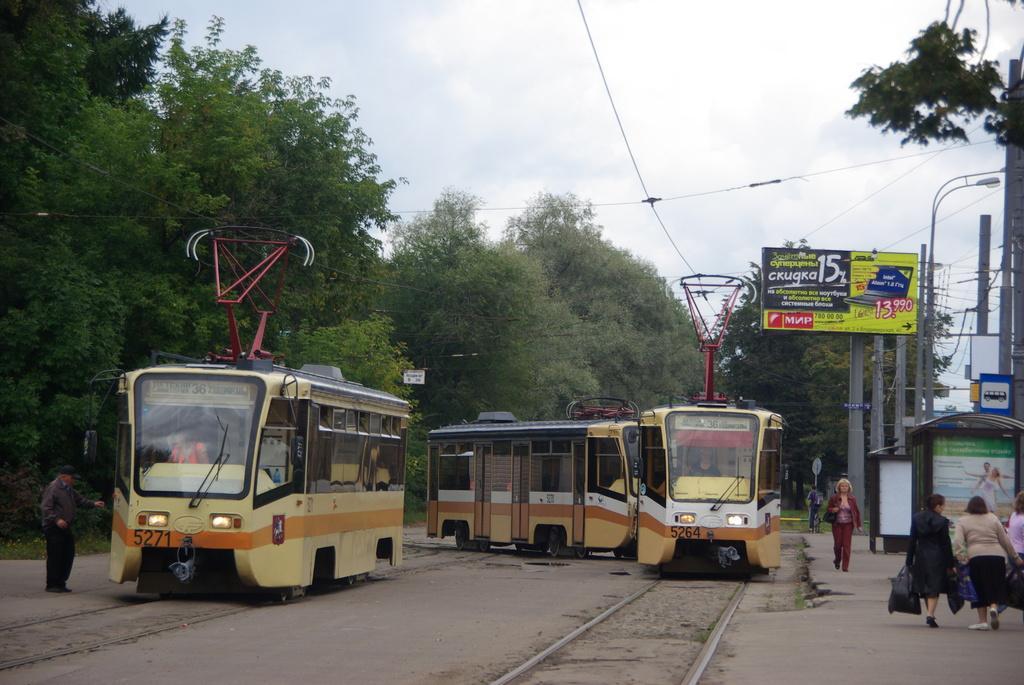How would you summarize this image in a sentence or two? In the image there are two vehicles, around the vehicles there are few people. On the right side there are poles and there are some wires attached to those poles and on the left side there are a lot of trees. 